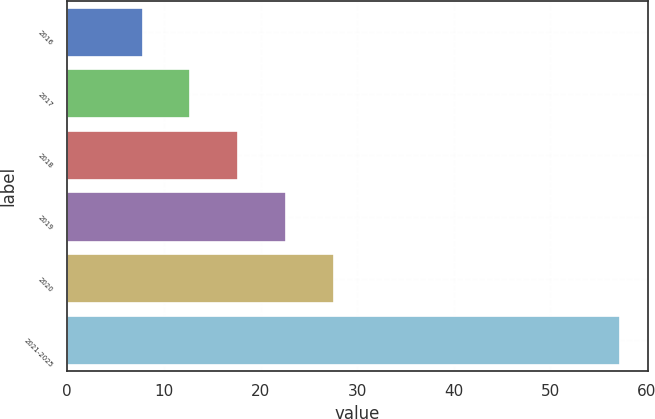Convert chart to OTSL. <chart><loc_0><loc_0><loc_500><loc_500><bar_chart><fcel>2016<fcel>2017<fcel>2018<fcel>2019<fcel>2020<fcel>2021-2025<nl><fcel>7.8<fcel>12.74<fcel>17.68<fcel>22.62<fcel>27.56<fcel>57.2<nl></chart> 